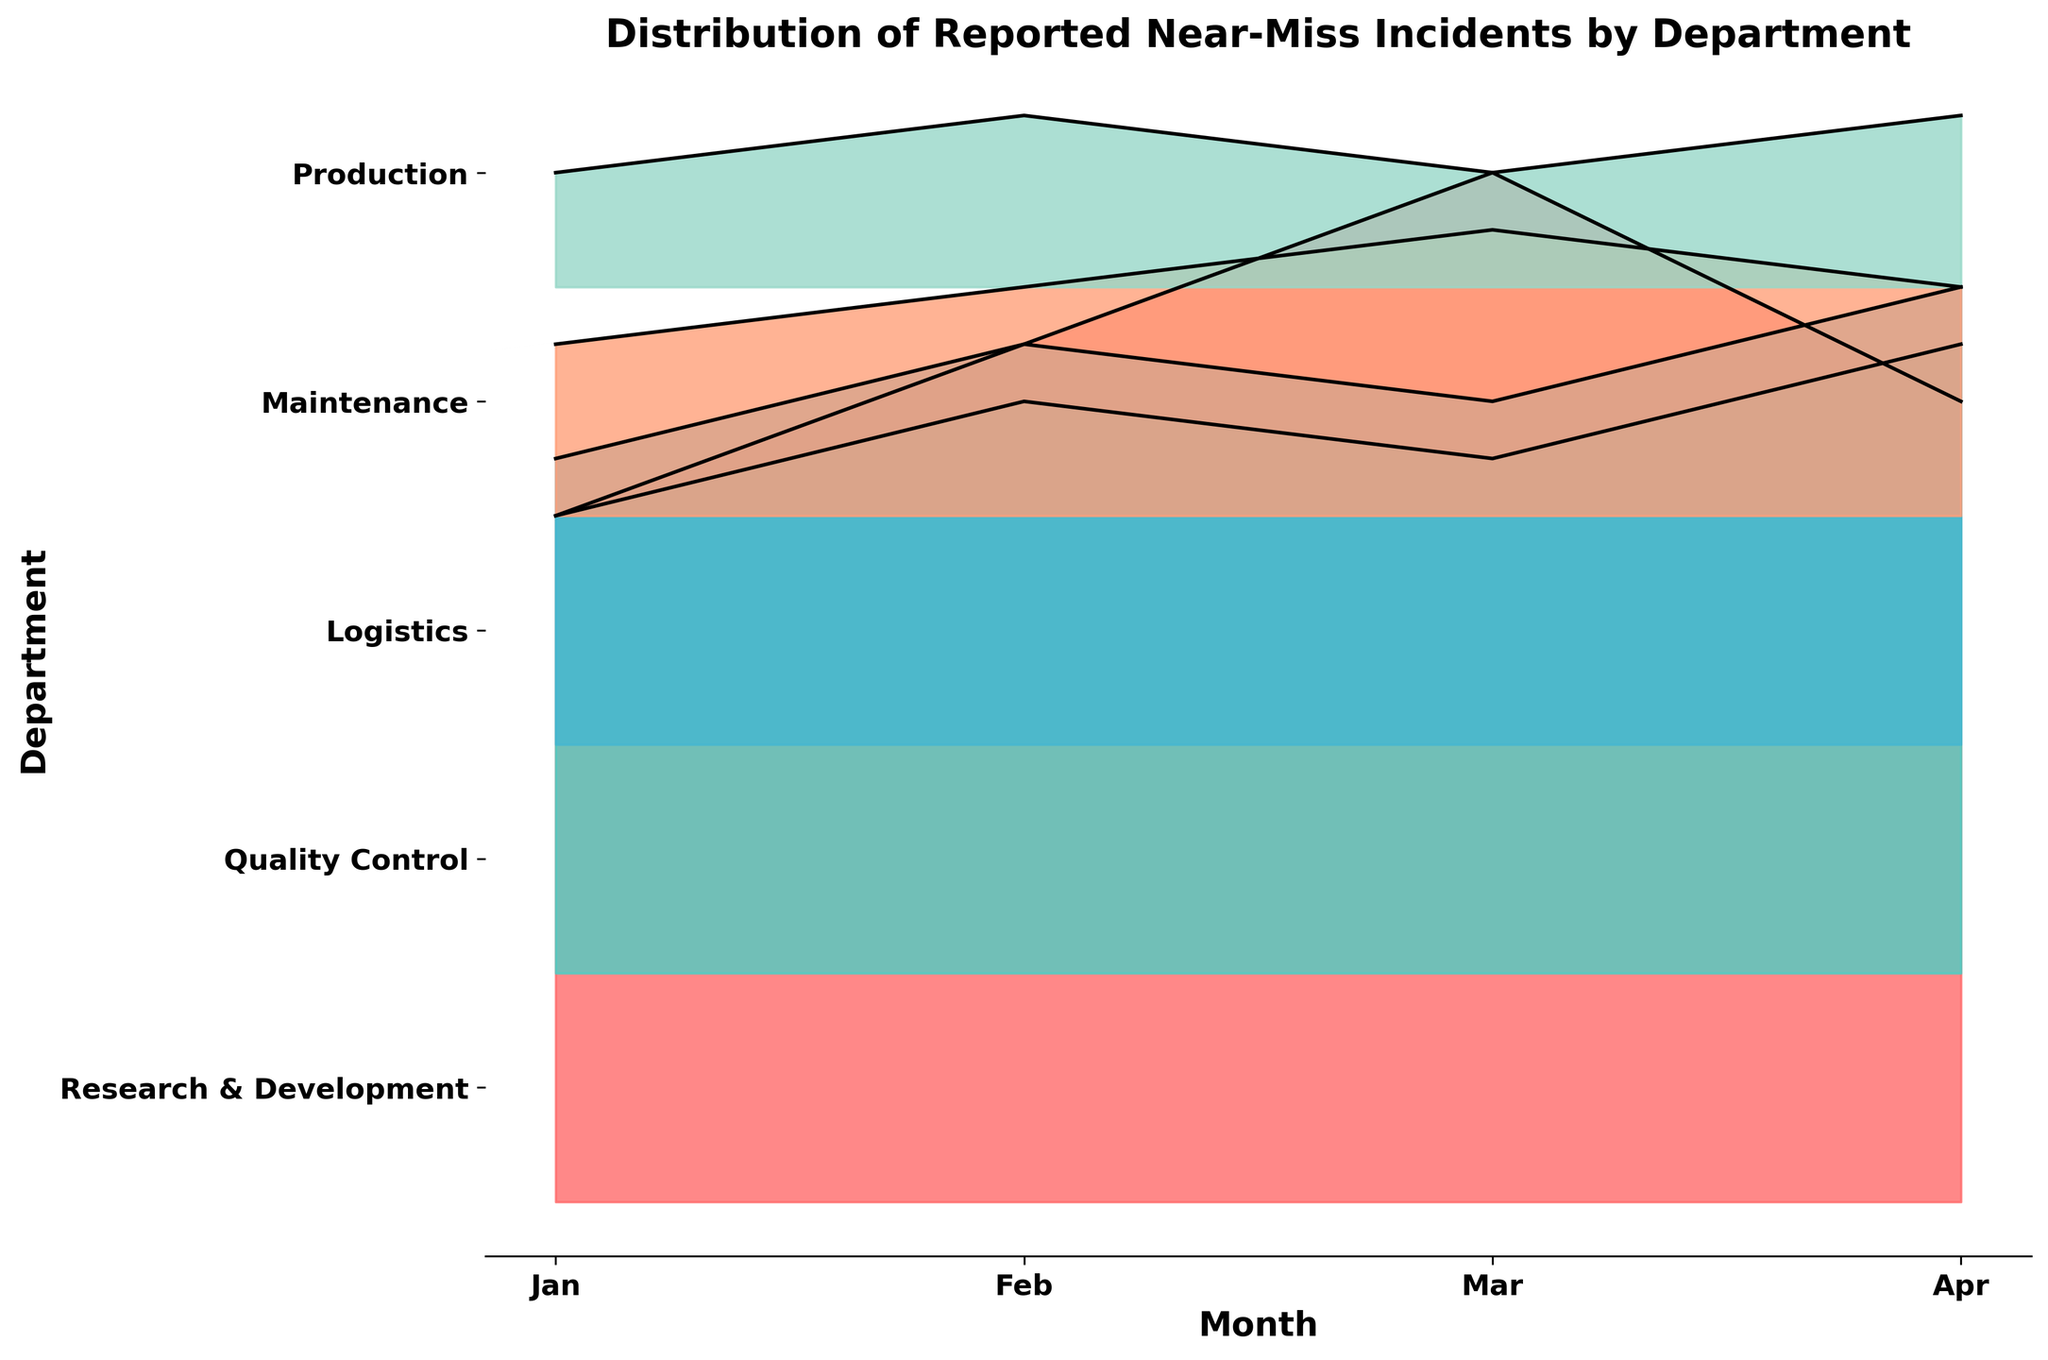What's the title of the figure? The title is usually located at the top of the figure. By reading the title at the top, we can determine that it is "Distribution of Reported Near-Miss Incidents by Department"
Answer: Distribution of Reported Near-Miss Incidents by Department What are the x-axis labels? The x-axis labels represent the months. We can see the labels "Jan", "Feb", "Mar", and "Apr" along the x-axis.
Answer: Jan, Feb, Mar, Apr Which department reported the most near-miss incidents in March? To find the department with the highest incidents in March, observe the peaks in the lines corresponding to March across all departments. The Production department has the highest peak.
Answer: Production How many departments reported near-miss incidents? By counting the names listed as y-axis labels, we see there are five departments.
Answer: 5 Which month had the lowest average near-miss incidents across all departments? Calculate the average incident count for each month (sum up incidents for all departments and divide by the number of departments). Compare these averages to find the lowest.
Answer: January Which department shows the least variation in reported near-miss incidents over the months? Least variation is indicated by the least change in heights for a single department across all months. Quality Control and Research & Development both show minimal variation.
Answer: Research & Development (tie with Quality Control) In which month did the Maintenance department report the highest number of incidents? Examine the line corresponding to Maintenance. The highest point for this line occurs in April.
Answer: April Which department had fewer incidents in February compared to January? Compare the heights for each department between January and February. Maintenance, Quality Control, and Research & Development all had increases, leaving Production and Logistics.
Answer: Logistics Considering all the departments, what is the trend for reported near-miss incidents from January to April? Visually analyzing the overall direction of the peaks from January to April, there is a slight upward trend, indicating an increase in incidents.
Answer: Upward trend 